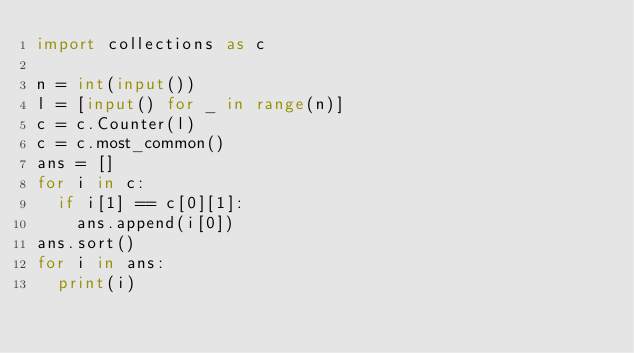<code> <loc_0><loc_0><loc_500><loc_500><_Python_>import collections as c

n = int(input())
l = [input() for _ in range(n)]
c = c.Counter(l)
c = c.most_common()
ans = []
for i in c:
  if i[1] == c[0][1]: 
    ans.append(i[0])
ans.sort()
for i in ans:
  print(i)</code> 